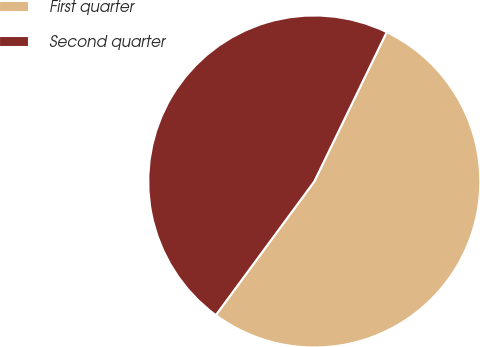<chart> <loc_0><loc_0><loc_500><loc_500><pie_chart><fcel>First quarter<fcel>Second quarter<nl><fcel>52.92%<fcel>47.08%<nl></chart> 